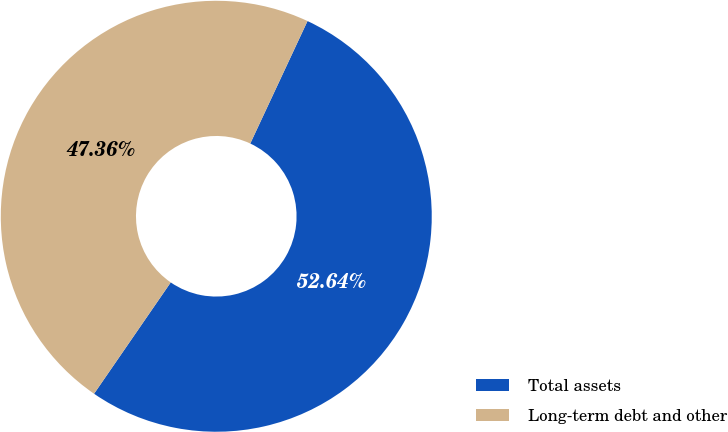Convert chart to OTSL. <chart><loc_0><loc_0><loc_500><loc_500><pie_chart><fcel>Total assets<fcel>Long-term debt and other<nl><fcel>52.64%<fcel>47.36%<nl></chart> 